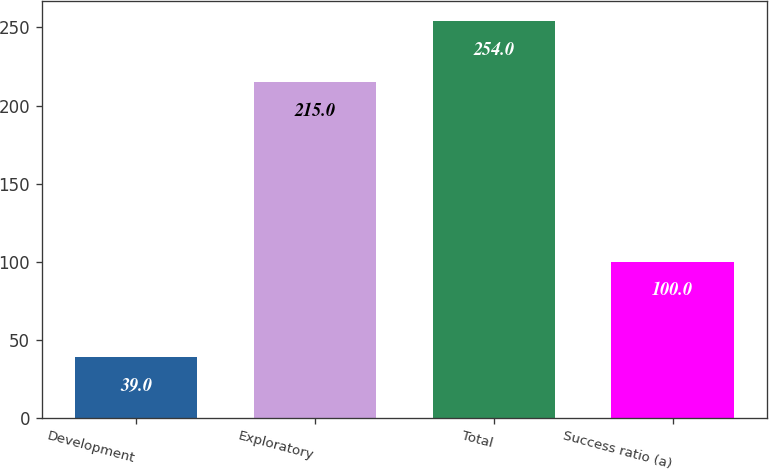Convert chart. <chart><loc_0><loc_0><loc_500><loc_500><bar_chart><fcel>Development<fcel>Exploratory<fcel>Total<fcel>Success ratio (a)<nl><fcel>39<fcel>215<fcel>254<fcel>100<nl></chart> 